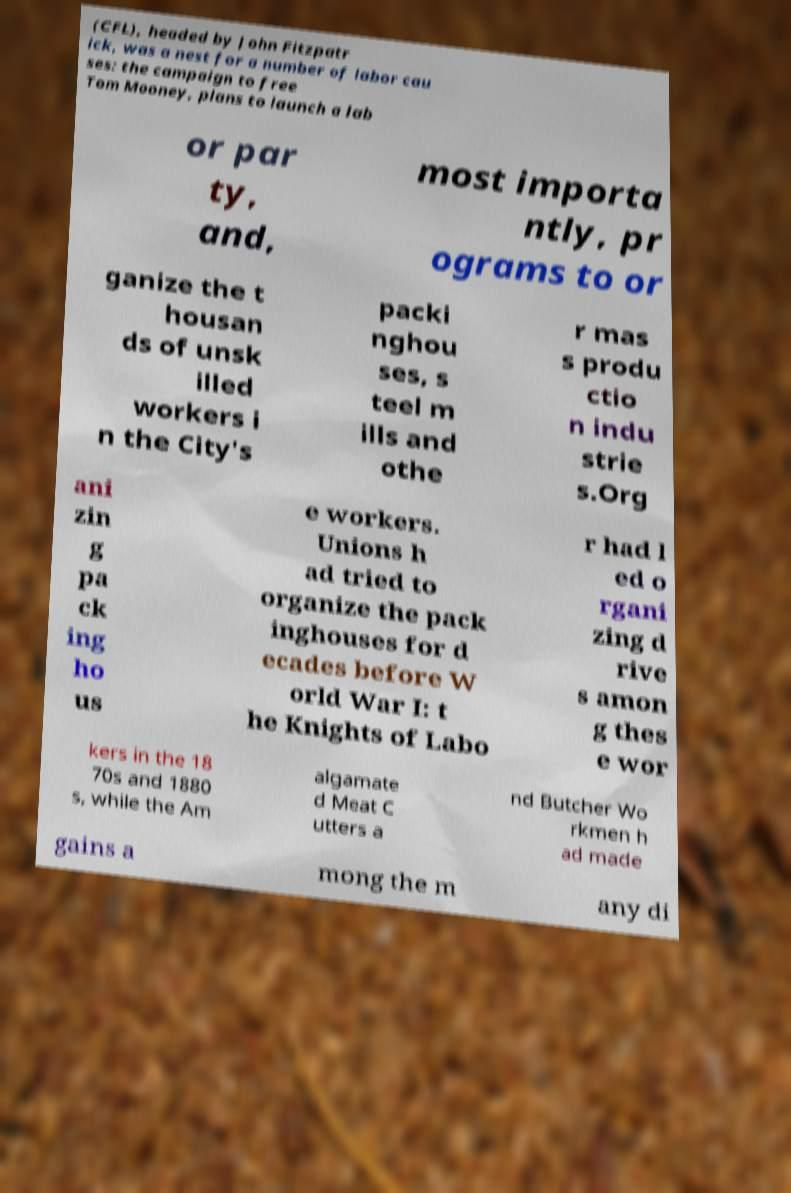I need the written content from this picture converted into text. Can you do that? (CFL), headed by John Fitzpatr ick, was a nest for a number of labor cau ses: the campaign to free Tom Mooney, plans to launch a lab or par ty, and, most importa ntly, pr ograms to or ganize the t housan ds of unsk illed workers i n the City's packi nghou ses, s teel m ills and othe r mas s produ ctio n indu strie s.Org ani zin g pa ck ing ho us e workers. Unions h ad tried to organize the pack inghouses for d ecades before W orld War I: t he Knights of Labo r had l ed o rgani zing d rive s amon g thes e wor kers in the 18 70s and 1880 s, while the Am algamate d Meat C utters a nd Butcher Wo rkmen h ad made gains a mong the m any di 